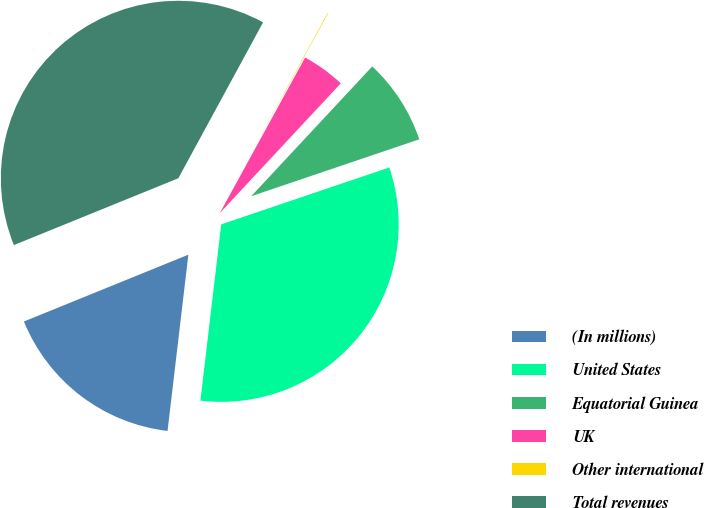Convert chart. <chart><loc_0><loc_0><loc_500><loc_500><pie_chart><fcel>(In millions)<fcel>United States<fcel>Equatorial Guinea<fcel>UK<fcel>Other international<fcel>Total revenues<nl><fcel>16.99%<fcel>32.07%<fcel>7.86%<fcel>3.96%<fcel>0.06%<fcel>39.07%<nl></chart> 